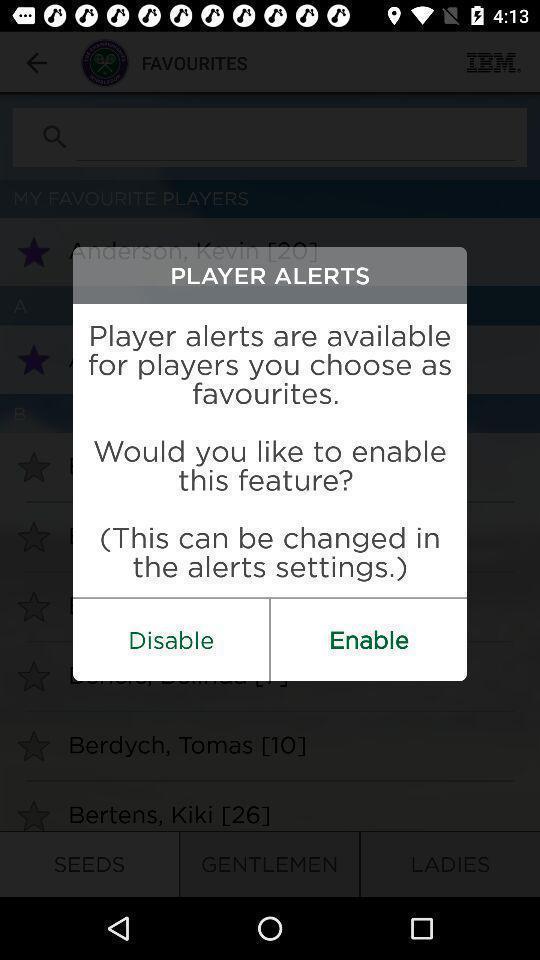Explain what's happening in this screen capture. Pop-up window showing enabling options for alerts. 